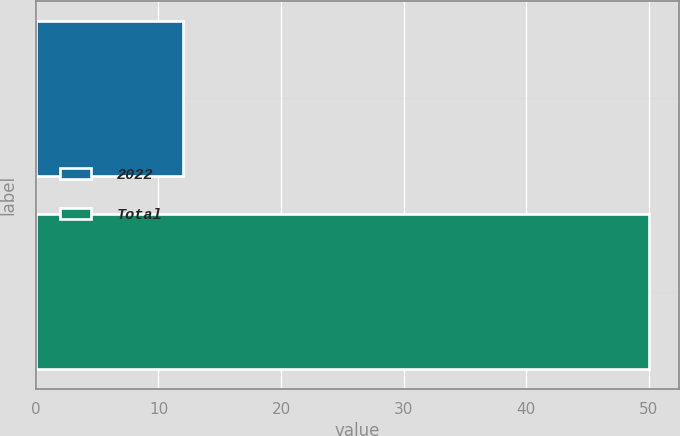Convert chart. <chart><loc_0><loc_0><loc_500><loc_500><bar_chart><fcel>2022<fcel>Total<nl><fcel>12<fcel>50<nl></chart> 